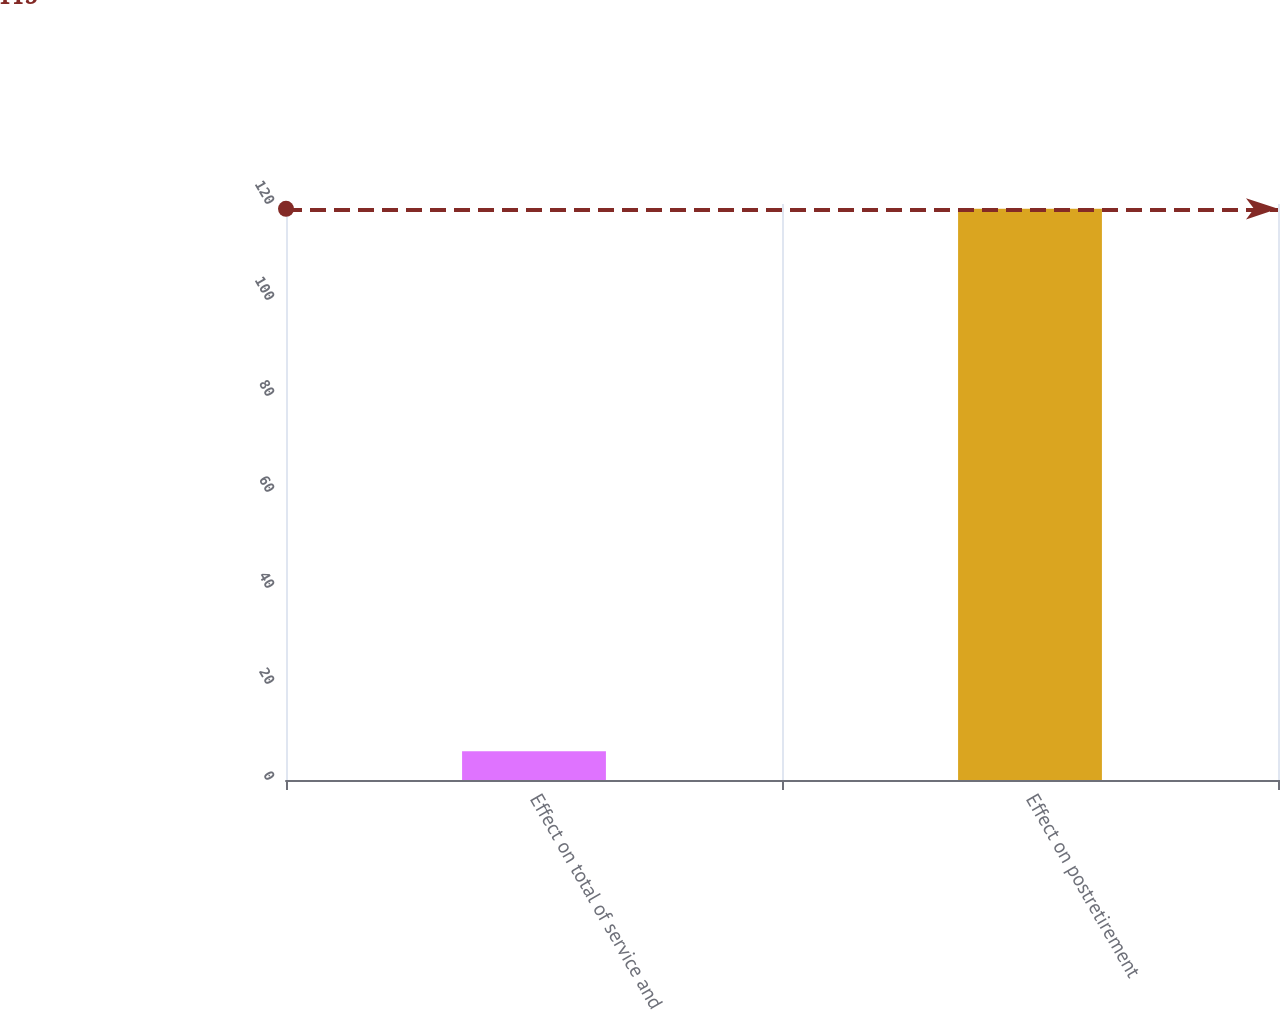Convert chart. <chart><loc_0><loc_0><loc_500><loc_500><bar_chart><fcel>Effect on total of service and<fcel>Effect on postretirement<nl><fcel>6<fcel>119<nl></chart> 